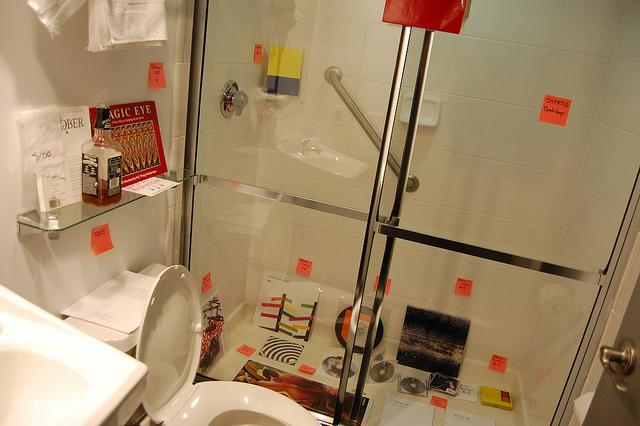What is near the bottle of alcohol? Please explain your reasoning. toilet. The bottle is by the toilet. 